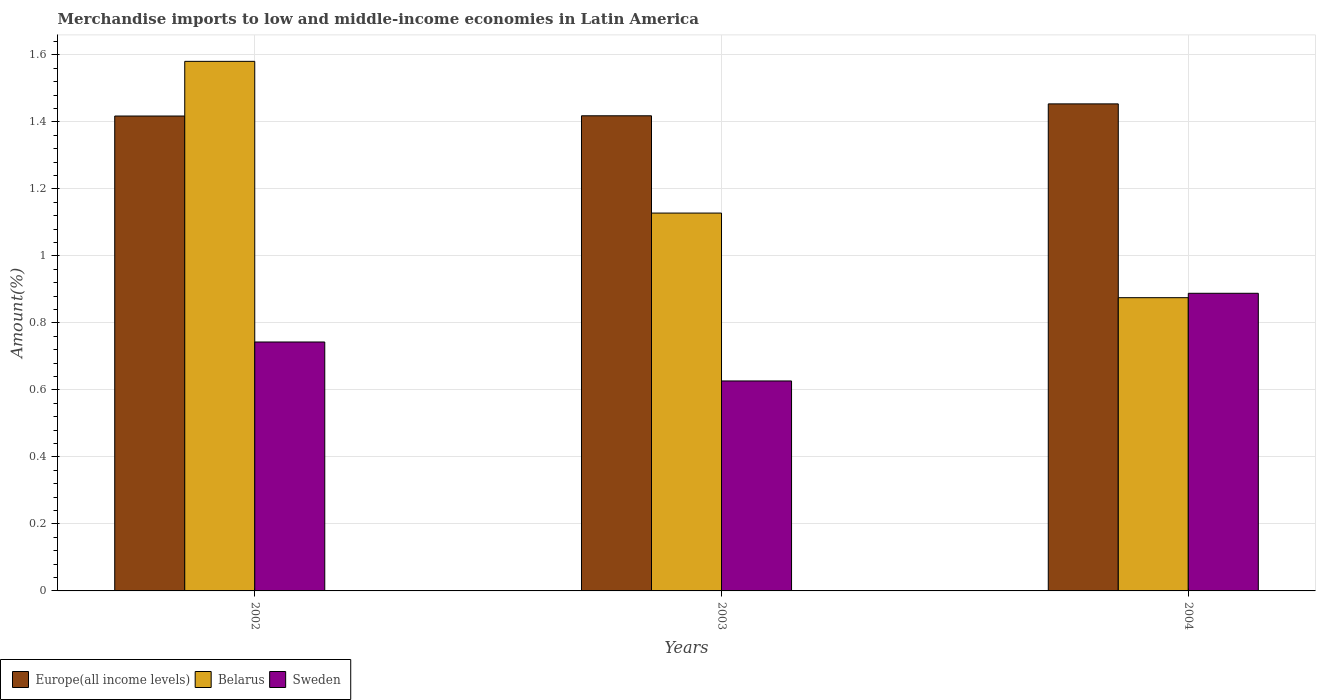How many different coloured bars are there?
Offer a very short reply. 3. Are the number of bars on each tick of the X-axis equal?
Your answer should be very brief. Yes. What is the label of the 1st group of bars from the left?
Offer a terse response. 2002. What is the percentage of amount earned from merchandise imports in Sweden in 2002?
Your response must be concise. 0.74. Across all years, what is the maximum percentage of amount earned from merchandise imports in Belarus?
Keep it short and to the point. 1.58. Across all years, what is the minimum percentage of amount earned from merchandise imports in Belarus?
Provide a short and direct response. 0.88. What is the total percentage of amount earned from merchandise imports in Sweden in the graph?
Your answer should be compact. 2.26. What is the difference between the percentage of amount earned from merchandise imports in Sweden in 2003 and that in 2004?
Give a very brief answer. -0.26. What is the difference between the percentage of amount earned from merchandise imports in Sweden in 2003 and the percentage of amount earned from merchandise imports in Belarus in 2002?
Your answer should be very brief. -0.95. What is the average percentage of amount earned from merchandise imports in Belarus per year?
Provide a short and direct response. 1.19. In the year 2004, what is the difference between the percentage of amount earned from merchandise imports in Europe(all income levels) and percentage of amount earned from merchandise imports in Belarus?
Your answer should be compact. 0.58. What is the ratio of the percentage of amount earned from merchandise imports in Europe(all income levels) in 2002 to that in 2003?
Keep it short and to the point. 1. Is the difference between the percentage of amount earned from merchandise imports in Europe(all income levels) in 2002 and 2004 greater than the difference between the percentage of amount earned from merchandise imports in Belarus in 2002 and 2004?
Your answer should be very brief. No. What is the difference between the highest and the second highest percentage of amount earned from merchandise imports in Europe(all income levels)?
Your answer should be very brief. 0.04. What is the difference between the highest and the lowest percentage of amount earned from merchandise imports in Belarus?
Provide a succinct answer. 0.71. In how many years, is the percentage of amount earned from merchandise imports in Belarus greater than the average percentage of amount earned from merchandise imports in Belarus taken over all years?
Provide a short and direct response. 1. What does the 1st bar from the left in 2004 represents?
Offer a terse response. Europe(all income levels). What does the 3rd bar from the right in 2004 represents?
Offer a terse response. Europe(all income levels). Is it the case that in every year, the sum of the percentage of amount earned from merchandise imports in Sweden and percentage of amount earned from merchandise imports in Europe(all income levels) is greater than the percentage of amount earned from merchandise imports in Belarus?
Offer a very short reply. Yes. How many bars are there?
Give a very brief answer. 9. Where does the legend appear in the graph?
Provide a short and direct response. Bottom left. What is the title of the graph?
Offer a terse response. Merchandise imports to low and middle-income economies in Latin America. What is the label or title of the Y-axis?
Offer a very short reply. Amount(%). What is the Amount(%) in Europe(all income levels) in 2002?
Keep it short and to the point. 1.42. What is the Amount(%) of Belarus in 2002?
Your answer should be very brief. 1.58. What is the Amount(%) in Sweden in 2002?
Offer a very short reply. 0.74. What is the Amount(%) in Europe(all income levels) in 2003?
Make the answer very short. 1.42. What is the Amount(%) in Belarus in 2003?
Offer a very short reply. 1.13. What is the Amount(%) in Sweden in 2003?
Keep it short and to the point. 0.63. What is the Amount(%) of Europe(all income levels) in 2004?
Provide a succinct answer. 1.45. What is the Amount(%) of Belarus in 2004?
Give a very brief answer. 0.88. What is the Amount(%) in Sweden in 2004?
Give a very brief answer. 0.89. Across all years, what is the maximum Amount(%) in Europe(all income levels)?
Your response must be concise. 1.45. Across all years, what is the maximum Amount(%) of Belarus?
Make the answer very short. 1.58. Across all years, what is the maximum Amount(%) of Sweden?
Ensure brevity in your answer.  0.89. Across all years, what is the minimum Amount(%) in Europe(all income levels)?
Give a very brief answer. 1.42. Across all years, what is the minimum Amount(%) of Belarus?
Your response must be concise. 0.88. Across all years, what is the minimum Amount(%) in Sweden?
Provide a succinct answer. 0.63. What is the total Amount(%) of Europe(all income levels) in the graph?
Give a very brief answer. 4.29. What is the total Amount(%) in Belarus in the graph?
Your response must be concise. 3.58. What is the total Amount(%) of Sweden in the graph?
Ensure brevity in your answer.  2.26. What is the difference between the Amount(%) in Europe(all income levels) in 2002 and that in 2003?
Ensure brevity in your answer.  -0. What is the difference between the Amount(%) of Belarus in 2002 and that in 2003?
Provide a succinct answer. 0.45. What is the difference between the Amount(%) of Sweden in 2002 and that in 2003?
Your answer should be compact. 0.12. What is the difference between the Amount(%) in Europe(all income levels) in 2002 and that in 2004?
Your answer should be compact. -0.04. What is the difference between the Amount(%) in Belarus in 2002 and that in 2004?
Offer a very short reply. 0.71. What is the difference between the Amount(%) of Sweden in 2002 and that in 2004?
Your response must be concise. -0.15. What is the difference between the Amount(%) of Europe(all income levels) in 2003 and that in 2004?
Offer a terse response. -0.04. What is the difference between the Amount(%) in Belarus in 2003 and that in 2004?
Make the answer very short. 0.25. What is the difference between the Amount(%) in Sweden in 2003 and that in 2004?
Your answer should be compact. -0.26. What is the difference between the Amount(%) in Europe(all income levels) in 2002 and the Amount(%) in Belarus in 2003?
Offer a very short reply. 0.29. What is the difference between the Amount(%) in Europe(all income levels) in 2002 and the Amount(%) in Sweden in 2003?
Ensure brevity in your answer.  0.79. What is the difference between the Amount(%) in Belarus in 2002 and the Amount(%) in Sweden in 2003?
Give a very brief answer. 0.95. What is the difference between the Amount(%) in Europe(all income levels) in 2002 and the Amount(%) in Belarus in 2004?
Your answer should be compact. 0.54. What is the difference between the Amount(%) in Europe(all income levels) in 2002 and the Amount(%) in Sweden in 2004?
Make the answer very short. 0.53. What is the difference between the Amount(%) of Belarus in 2002 and the Amount(%) of Sweden in 2004?
Provide a succinct answer. 0.69. What is the difference between the Amount(%) in Europe(all income levels) in 2003 and the Amount(%) in Belarus in 2004?
Provide a succinct answer. 0.54. What is the difference between the Amount(%) in Europe(all income levels) in 2003 and the Amount(%) in Sweden in 2004?
Provide a succinct answer. 0.53. What is the difference between the Amount(%) of Belarus in 2003 and the Amount(%) of Sweden in 2004?
Your answer should be very brief. 0.24. What is the average Amount(%) in Europe(all income levels) per year?
Your answer should be very brief. 1.43. What is the average Amount(%) of Belarus per year?
Your response must be concise. 1.19. What is the average Amount(%) in Sweden per year?
Offer a terse response. 0.75. In the year 2002, what is the difference between the Amount(%) in Europe(all income levels) and Amount(%) in Belarus?
Provide a short and direct response. -0.16. In the year 2002, what is the difference between the Amount(%) of Europe(all income levels) and Amount(%) of Sweden?
Give a very brief answer. 0.67. In the year 2002, what is the difference between the Amount(%) in Belarus and Amount(%) in Sweden?
Provide a short and direct response. 0.84. In the year 2003, what is the difference between the Amount(%) in Europe(all income levels) and Amount(%) in Belarus?
Your answer should be compact. 0.29. In the year 2003, what is the difference between the Amount(%) in Europe(all income levels) and Amount(%) in Sweden?
Offer a terse response. 0.79. In the year 2003, what is the difference between the Amount(%) in Belarus and Amount(%) in Sweden?
Give a very brief answer. 0.5. In the year 2004, what is the difference between the Amount(%) in Europe(all income levels) and Amount(%) in Belarus?
Offer a very short reply. 0.58. In the year 2004, what is the difference between the Amount(%) of Europe(all income levels) and Amount(%) of Sweden?
Give a very brief answer. 0.57. In the year 2004, what is the difference between the Amount(%) in Belarus and Amount(%) in Sweden?
Keep it short and to the point. -0.01. What is the ratio of the Amount(%) of Europe(all income levels) in 2002 to that in 2003?
Offer a terse response. 1. What is the ratio of the Amount(%) in Belarus in 2002 to that in 2003?
Make the answer very short. 1.4. What is the ratio of the Amount(%) of Sweden in 2002 to that in 2003?
Ensure brevity in your answer.  1.19. What is the ratio of the Amount(%) of Europe(all income levels) in 2002 to that in 2004?
Keep it short and to the point. 0.98. What is the ratio of the Amount(%) in Belarus in 2002 to that in 2004?
Ensure brevity in your answer.  1.81. What is the ratio of the Amount(%) in Sweden in 2002 to that in 2004?
Your answer should be very brief. 0.84. What is the ratio of the Amount(%) of Europe(all income levels) in 2003 to that in 2004?
Your answer should be very brief. 0.98. What is the ratio of the Amount(%) of Belarus in 2003 to that in 2004?
Your answer should be very brief. 1.29. What is the ratio of the Amount(%) of Sweden in 2003 to that in 2004?
Offer a terse response. 0.71. What is the difference between the highest and the second highest Amount(%) of Europe(all income levels)?
Your answer should be compact. 0.04. What is the difference between the highest and the second highest Amount(%) of Belarus?
Ensure brevity in your answer.  0.45. What is the difference between the highest and the second highest Amount(%) in Sweden?
Your answer should be compact. 0.15. What is the difference between the highest and the lowest Amount(%) of Europe(all income levels)?
Ensure brevity in your answer.  0.04. What is the difference between the highest and the lowest Amount(%) in Belarus?
Provide a succinct answer. 0.71. What is the difference between the highest and the lowest Amount(%) in Sweden?
Offer a very short reply. 0.26. 